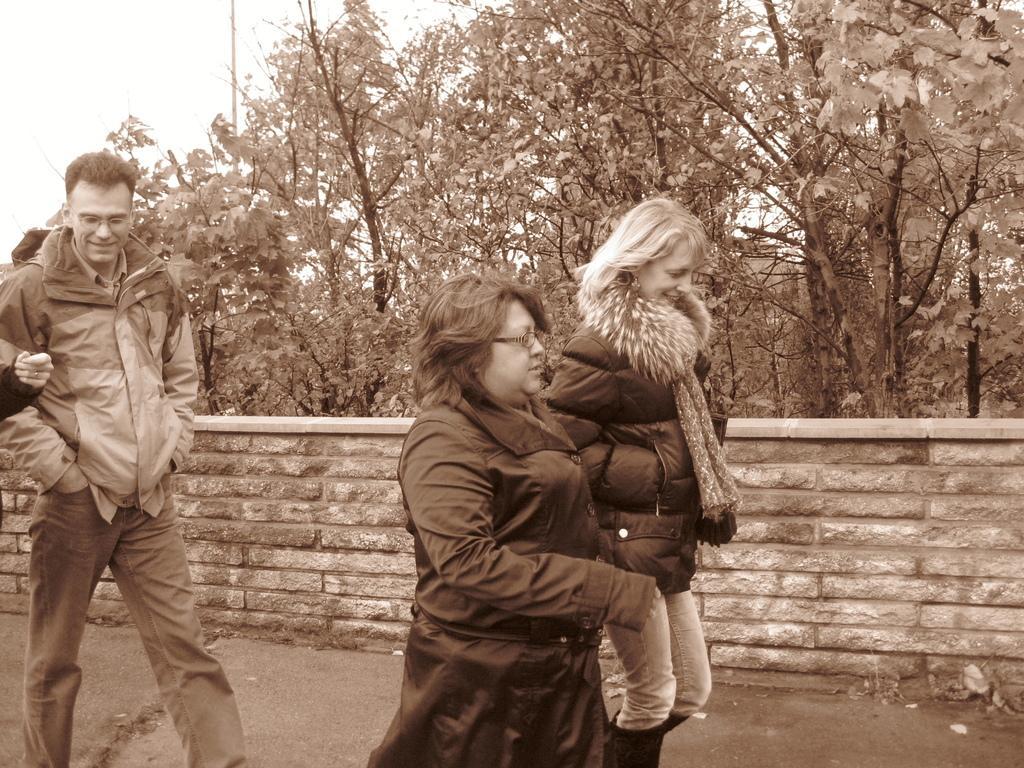In one or two sentences, can you explain what this image depicts? In the picture we can see two women and a man are walking on the path they are wearing a jacket and hoodie and in the background, we can see a wall and behind it we can see trees and sky. 